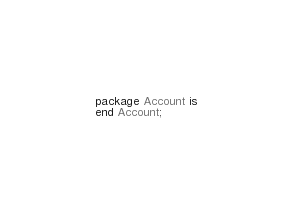Convert code to text. <code><loc_0><loc_0><loc_500><loc_500><_Ada_>package Account is
end Account;
</code> 